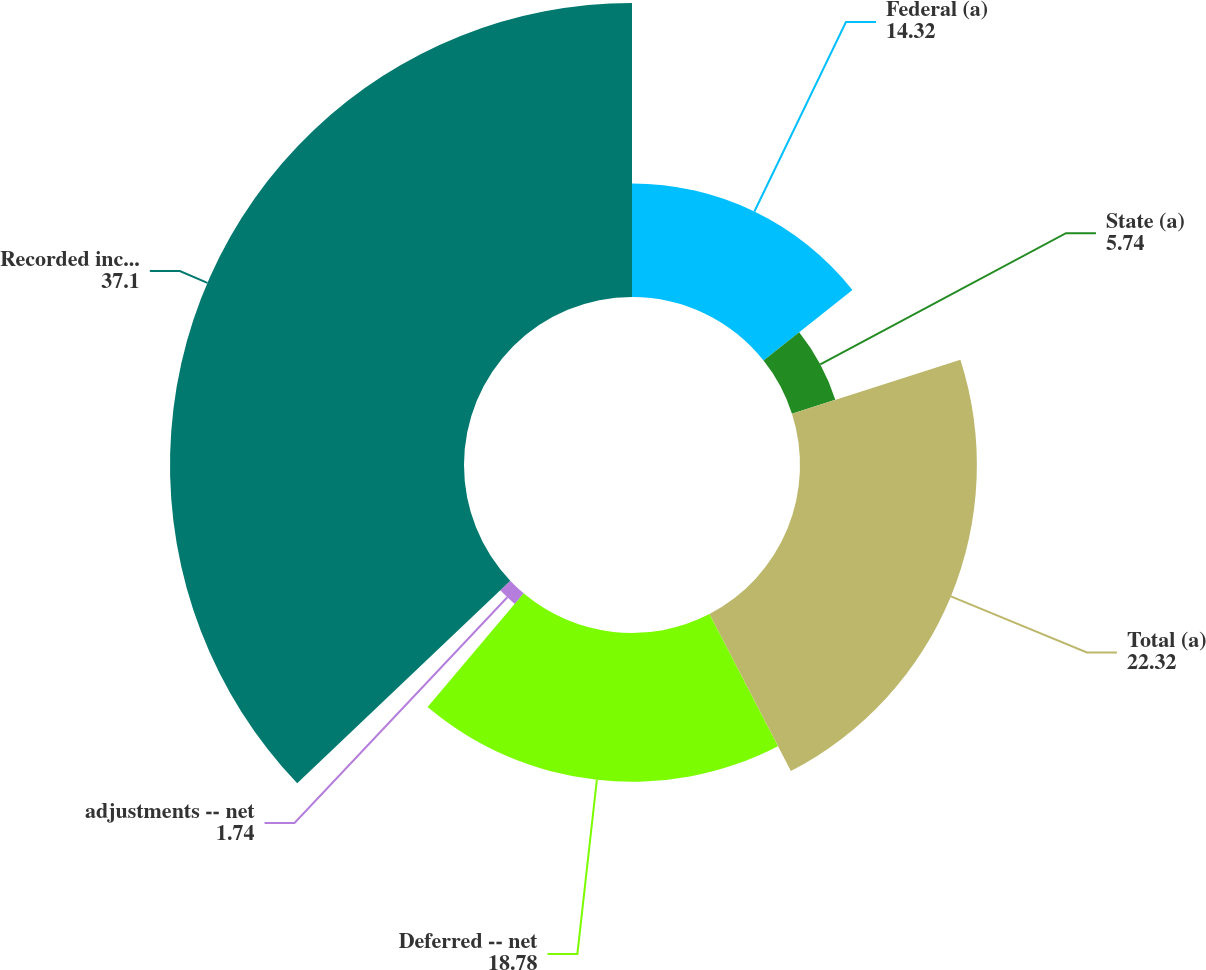Convert chart to OTSL. <chart><loc_0><loc_0><loc_500><loc_500><pie_chart><fcel>Federal (a)<fcel>State (a)<fcel>Total (a)<fcel>Deferred -- net<fcel>adjustments -- net<fcel>Recorded income tax expense<nl><fcel>14.32%<fcel>5.74%<fcel>22.32%<fcel>18.78%<fcel>1.74%<fcel>37.1%<nl></chart> 